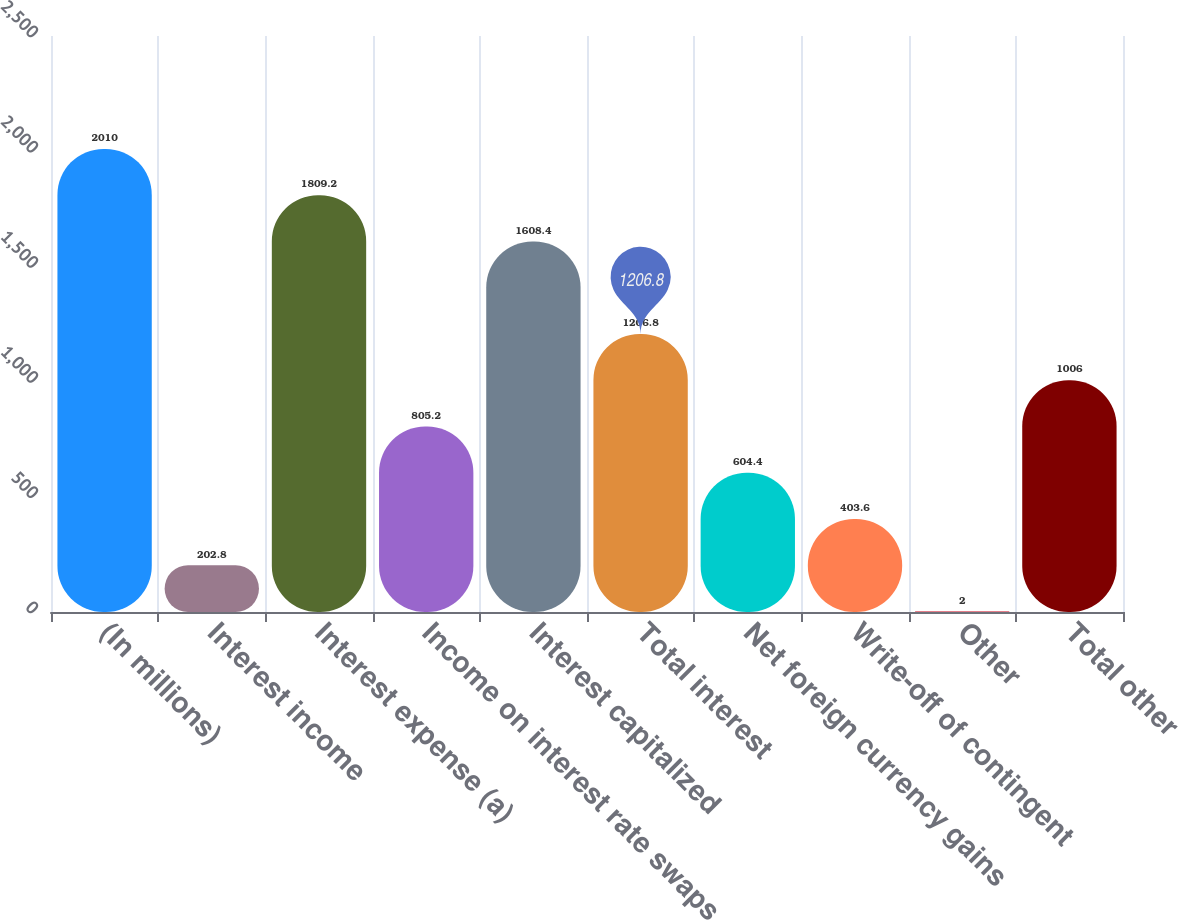Convert chart to OTSL. <chart><loc_0><loc_0><loc_500><loc_500><bar_chart><fcel>(In millions)<fcel>Interest income<fcel>Interest expense (a)<fcel>Income on interest rate swaps<fcel>Interest capitalized<fcel>Total interest<fcel>Net foreign currency gains<fcel>Write-off of contingent<fcel>Other<fcel>Total other<nl><fcel>2010<fcel>202.8<fcel>1809.2<fcel>805.2<fcel>1608.4<fcel>1206.8<fcel>604.4<fcel>403.6<fcel>2<fcel>1006<nl></chart> 